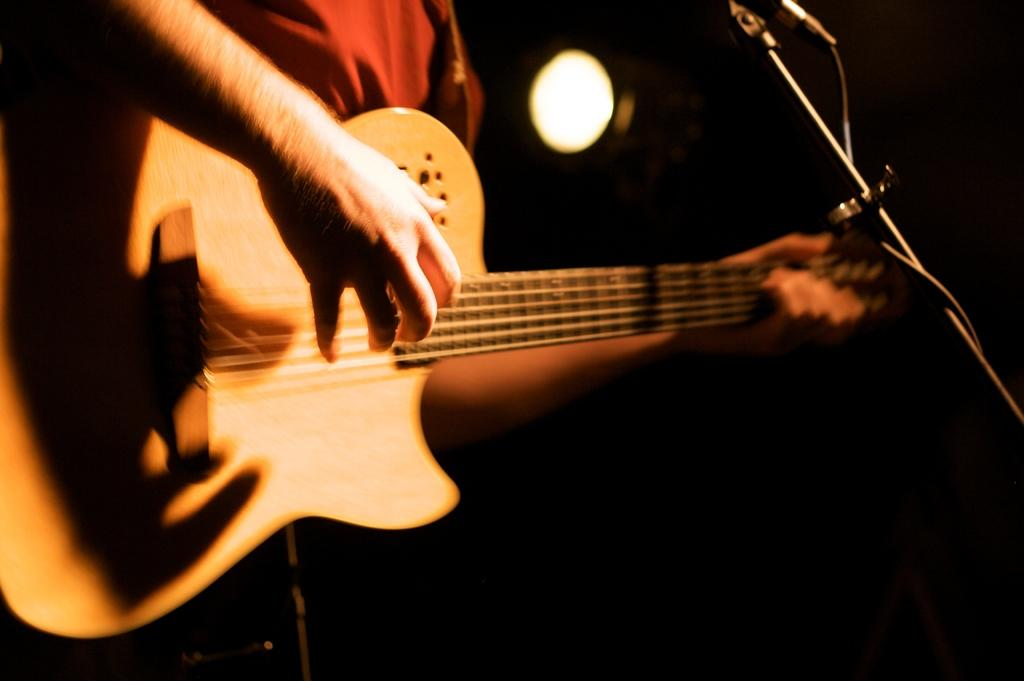What is the person in the image doing? There is a person playing a guitar in the image. What is the person using to amplify their voice? There is a microphone in the image, which has a stand. Where are the microphone and stand located in the image? The microphone and stand are on the right side of the image. What can be seen at the back of the image? There is a light at the back of the image. What is the color of the background in the image? The background of the image is black. What type of watch is the person wearing in the image? There is no watch visible in the image. What scientific theory is being discussed in the image? There is no discussion of a scientific theory in the image. 